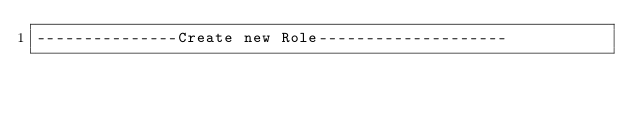<code> <loc_0><loc_0><loc_500><loc_500><_SQL_>---------------Create new Role--------------------</code> 